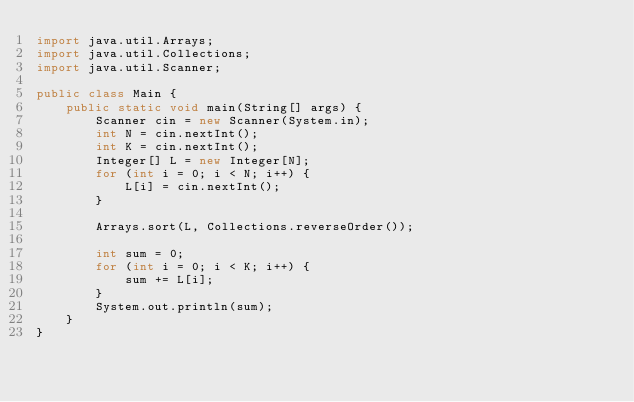<code> <loc_0><loc_0><loc_500><loc_500><_Java_>import java.util.Arrays;
import java.util.Collections;
import java.util.Scanner;

public class Main {
    public static void main(String[] args) {
        Scanner cin = new Scanner(System.in);
        int N = cin.nextInt();
        int K = cin.nextInt();
        Integer[] L = new Integer[N];
        for (int i = 0; i < N; i++) {
            L[i] = cin.nextInt();
        }

        Arrays.sort(L, Collections.reverseOrder());

        int sum = 0;
        for (int i = 0; i < K; i++) {
            sum += L[i];
        }
        System.out.println(sum);
    }
}</code> 